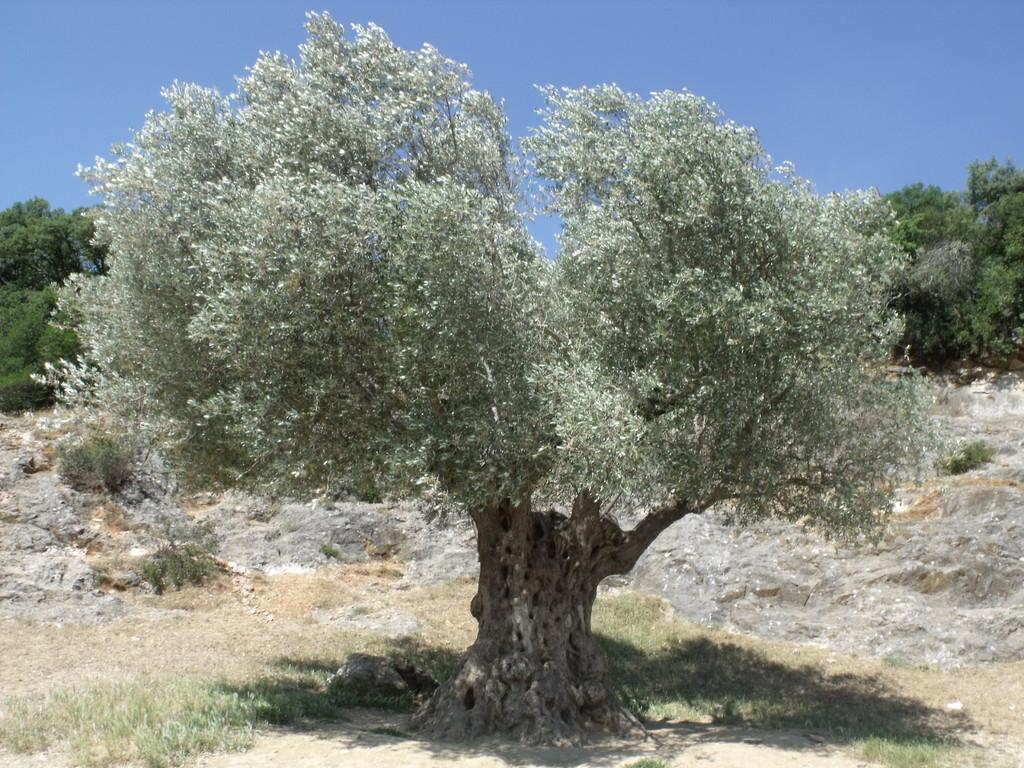What type of vegetation can be seen in the image? There is a group of trees in the image. What else can be seen on the ground in the image? There is grass visible in the image. What is visible in the background of the image? The sky is visible in the image. How many rings are hanging from the trees in the image? There are no rings present in the image; it features a group of trees, grass, and the sky. 